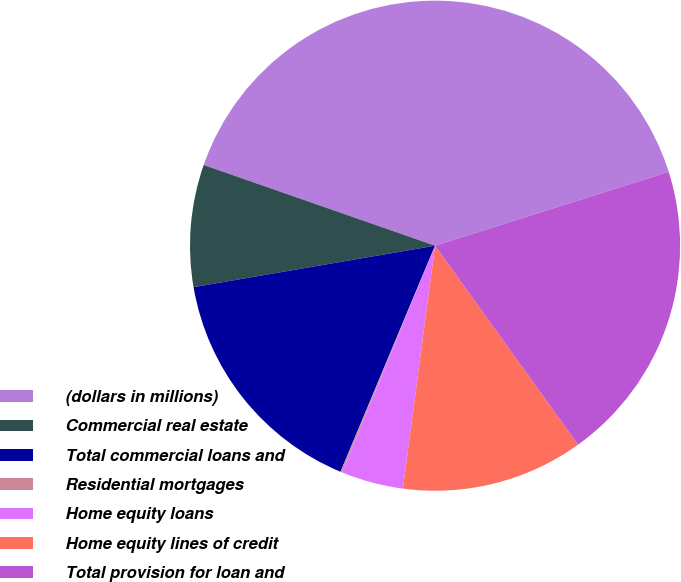Convert chart. <chart><loc_0><loc_0><loc_500><loc_500><pie_chart><fcel>(dollars in millions)<fcel>Commercial real estate<fcel>Total commercial loans and<fcel>Residential mortgages<fcel>Home equity loans<fcel>Home equity lines of credit<fcel>Total provision for loan and<nl><fcel>39.79%<fcel>8.05%<fcel>15.99%<fcel>0.12%<fcel>4.09%<fcel>12.02%<fcel>19.95%<nl></chart> 